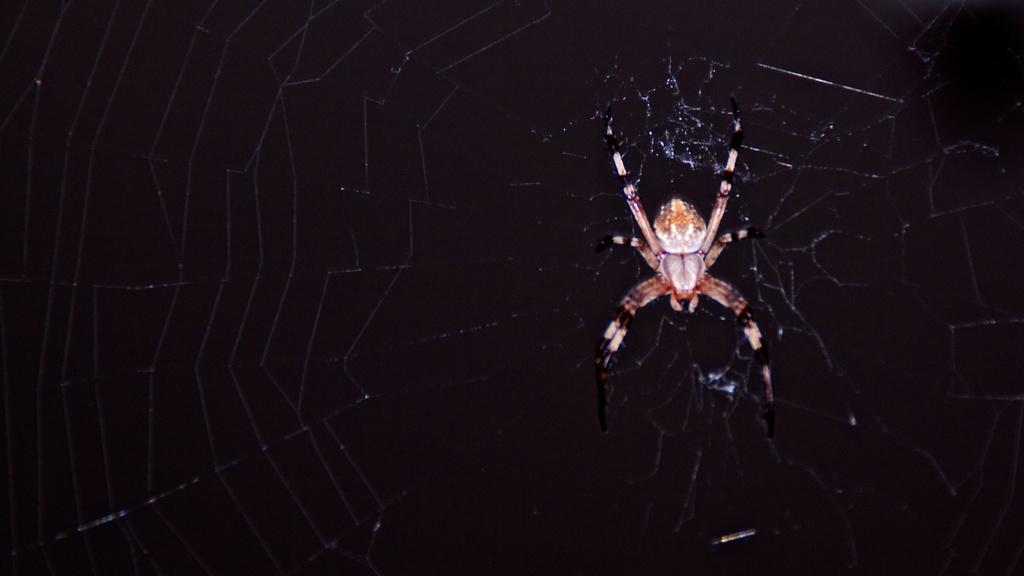What is the main subject of the image? The main subject of the image is a spider. Where is the spider located in the image? The spider is on a web. What can be observed about the background of the image? The background of the image is dark. What type of house is depicted in the image? There is no house depicted in the image; it features a spider on a web with a dark background. Can you describe the wallpaper pattern in the image? There is no wallpaper present in the image; it only shows a spider on a web with a dark background. 